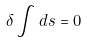Convert formula to latex. <formula><loc_0><loc_0><loc_500><loc_500>\delta \int d s = 0</formula> 